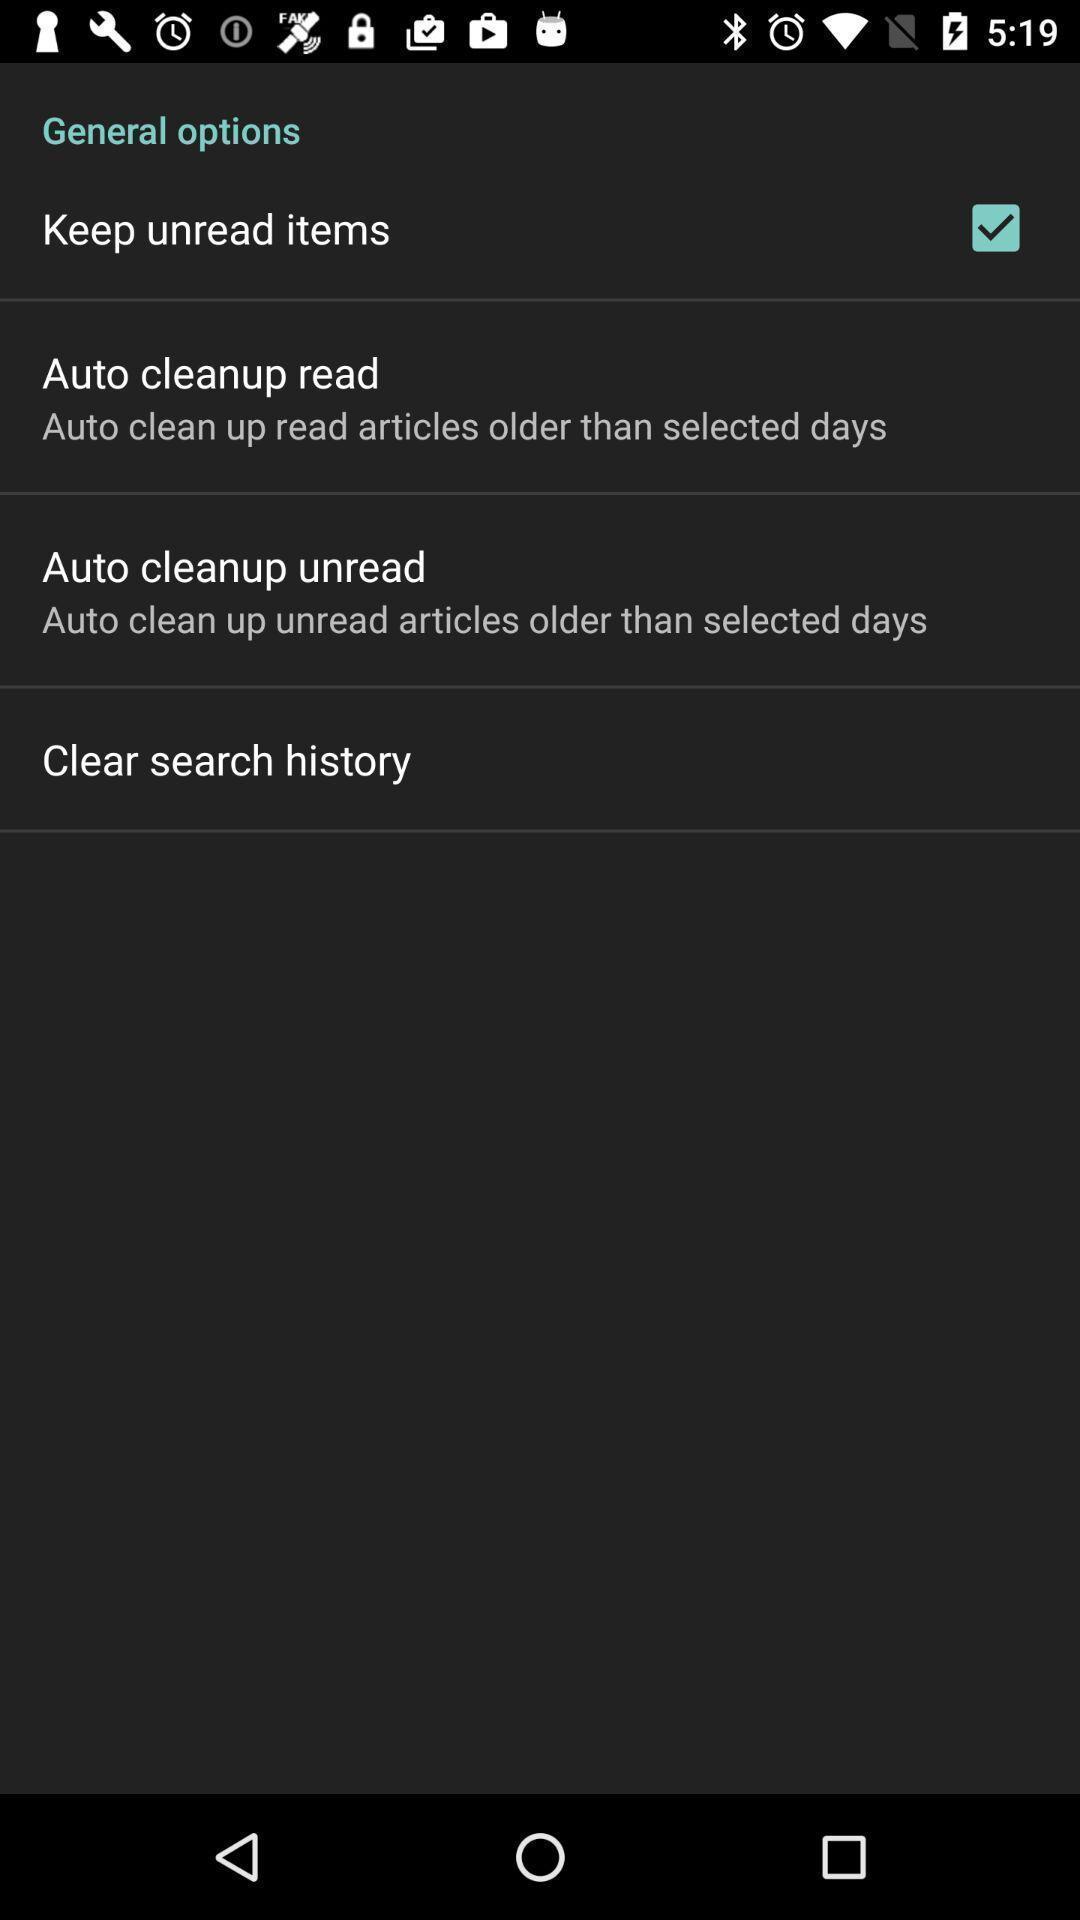What is the overall content of this screenshot? Screen displaying the list of options and check box. 